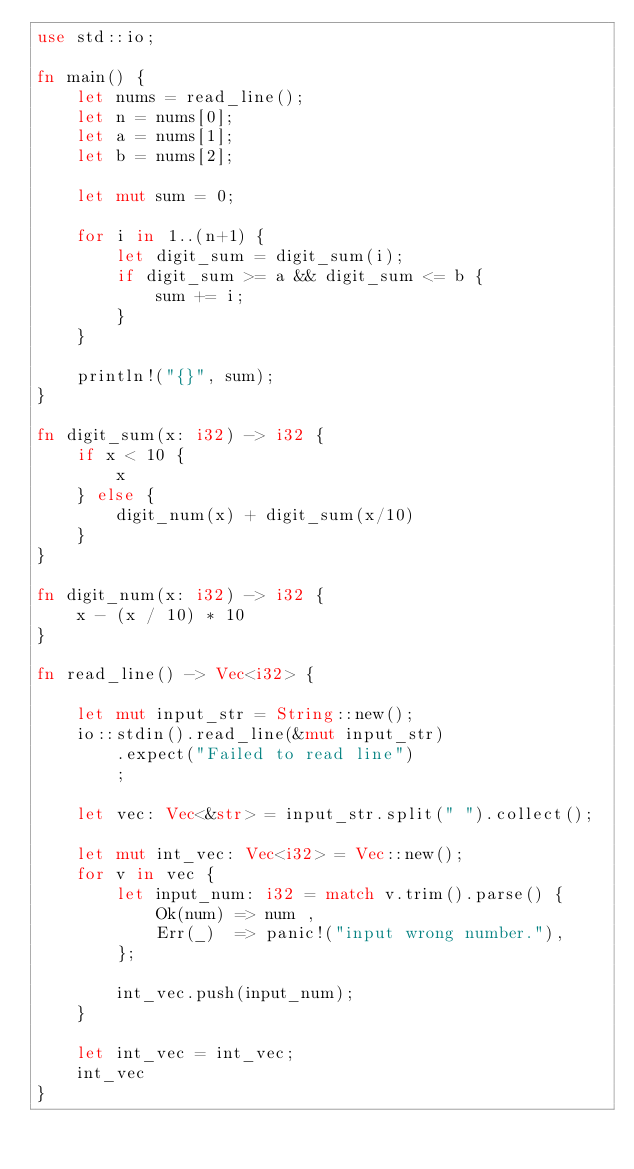Convert code to text. <code><loc_0><loc_0><loc_500><loc_500><_Rust_>use std::io;

fn main() {
    let nums = read_line();
    let n = nums[0];
    let a = nums[1];
    let b = nums[2];

    let mut sum = 0;

    for i in 1..(n+1) {
        let digit_sum = digit_sum(i);
        if digit_sum >= a && digit_sum <= b {
            sum += i;
        }
    }

    println!("{}", sum);
}

fn digit_sum(x: i32) -> i32 {
    if x < 10 {
        x
    } else {
        digit_num(x) + digit_sum(x/10)
    }
}

fn digit_num(x: i32) -> i32 {
    x - (x / 10) * 10
}

fn read_line() -> Vec<i32> {

    let mut input_str = String::new();
    io::stdin().read_line(&mut input_str)
        .expect("Failed to read line")
        ;

    let vec: Vec<&str> = input_str.split(" ").collect();

    let mut int_vec: Vec<i32> = Vec::new();
    for v in vec {
        let input_num: i32 = match v.trim().parse() {
            Ok(num) => num ,
            Err(_)  => panic!("input wrong number."),
        };

        int_vec.push(input_num);
    }

    let int_vec = int_vec;
    int_vec
}
</code> 